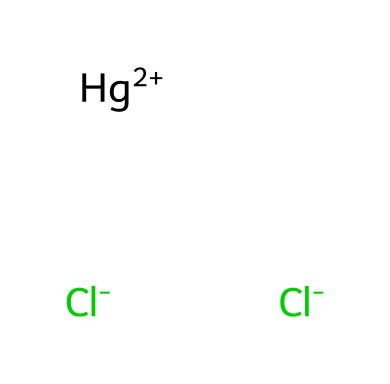What is the molecular formula of this chemical? The SMILES representation indicates the number of each type of atom present in the chemical. There are 2 chlorine atoms (Cl) and 1 mercury atom (Hg), leading to the molecular formula HgCl2.
Answer: HgCl2 How many chlorine atoms are in the structure? The SMILES notation shows two instances of the chlorine atom symbol (Cl-), which indicates there are two chlorine atoms present in the molecule.
Answer: 2 What is the charge of the mercury ion in this chemical? In the SMILES formula, the presence of Hg+2 indicates that the mercury ion has a charge of +2.
Answer: +2 Is mercury(II) chloride soluble in water? Mercury(II) chloride is known to have limited solubility in water, but is generally regarded as soluble in certain concentrations.
Answer: Yes Why is mercury(II) chloride considered hazardous? Mercury(II) chloride is toxic and can cause serious health issues, including damage to the kidneys and nervous system, which is why it is classified as hazardous.
Answer: Toxic What type of bonding is present between mercury and chlorine in this structure? The connection between mercury and chlorine atoms is indicative of ionic bonding since mercury (Hg) loses electrons to chlorine (Cl), leading to the formation of charged ions.
Answer: Ionic 